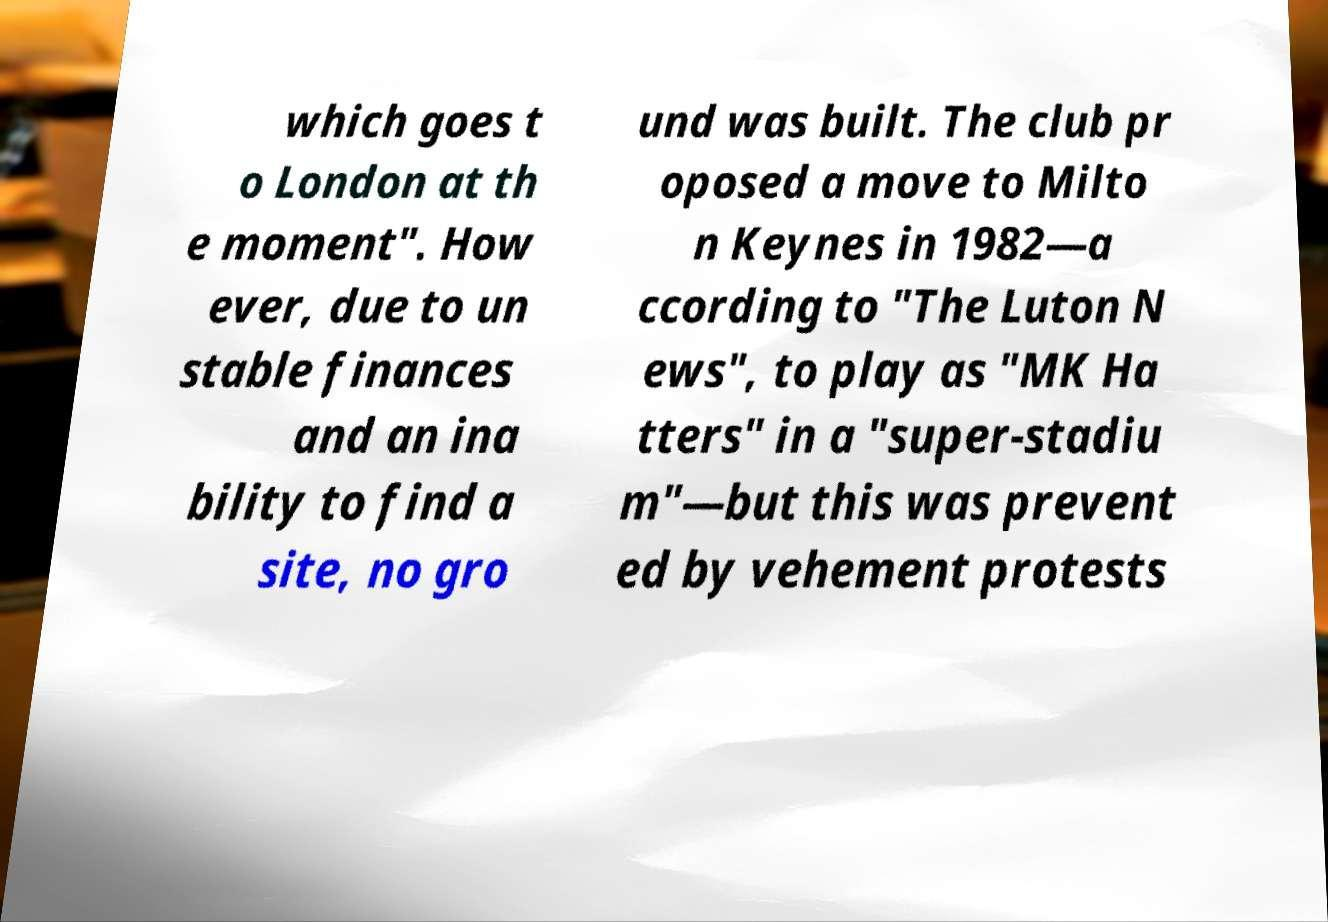Could you assist in decoding the text presented in this image and type it out clearly? which goes t o London at th e moment". How ever, due to un stable finances and an ina bility to find a site, no gro und was built. The club pr oposed a move to Milto n Keynes in 1982—a ccording to "The Luton N ews", to play as "MK Ha tters" in a "super-stadiu m"—but this was prevent ed by vehement protests 